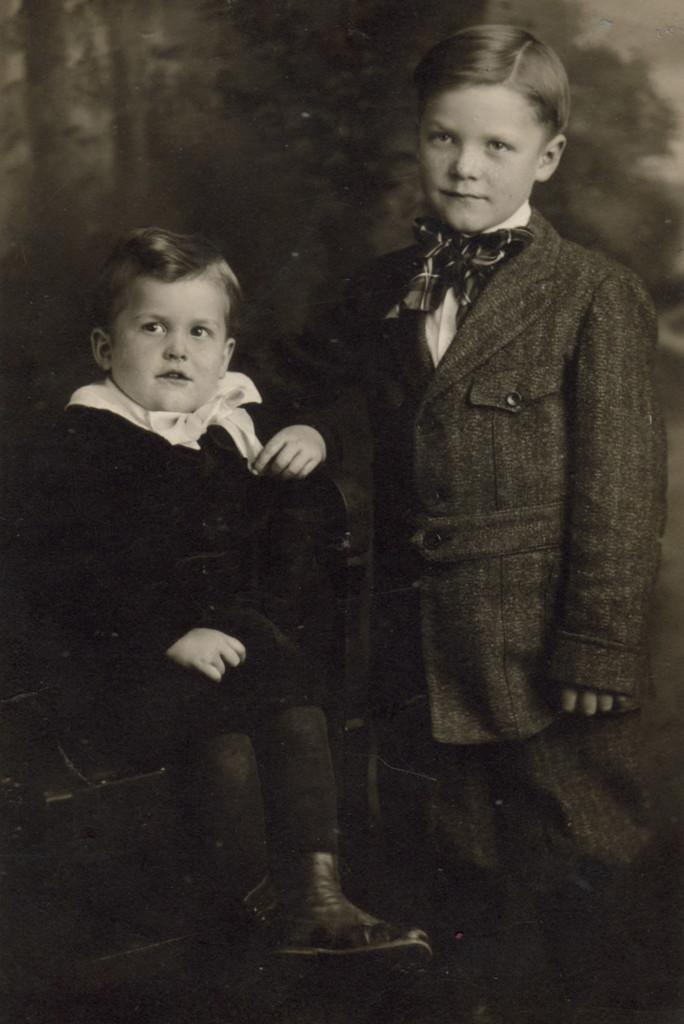How many children are present in the image? There are two kids in the image. Can you describe the background of the image? The background of the image is blurry. What type of account does the playground have in the image? There is no playground present in the image, so it is not possible to determine what type of account it might have. 